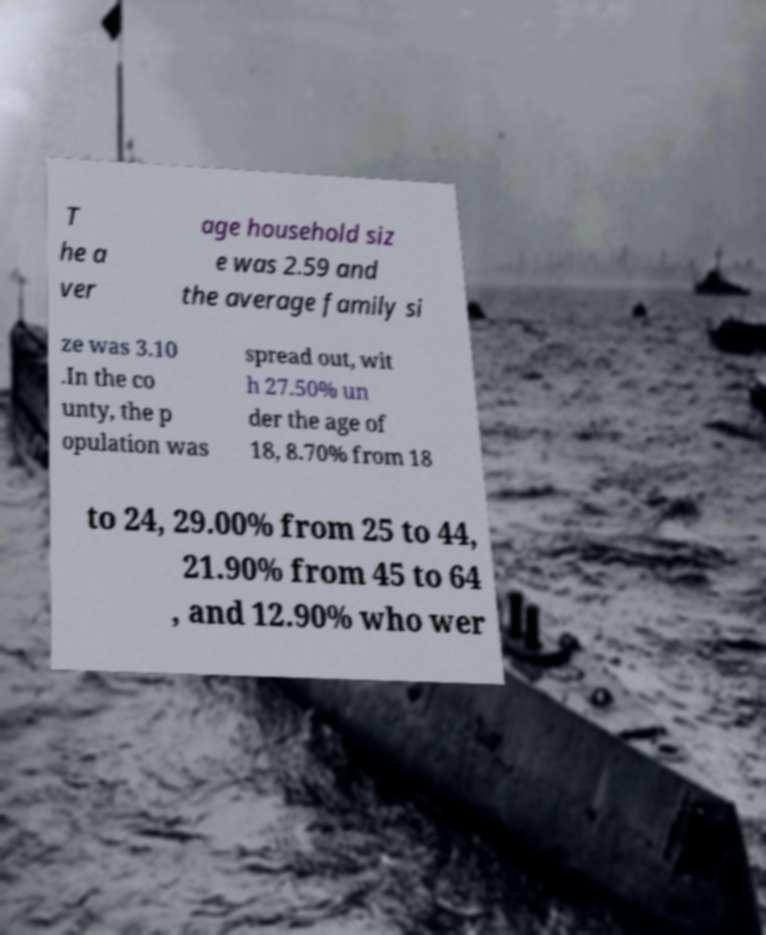There's text embedded in this image that I need extracted. Can you transcribe it verbatim? T he a ver age household siz e was 2.59 and the average family si ze was 3.10 .In the co unty, the p opulation was spread out, wit h 27.50% un der the age of 18, 8.70% from 18 to 24, 29.00% from 25 to 44, 21.90% from 45 to 64 , and 12.90% who wer 